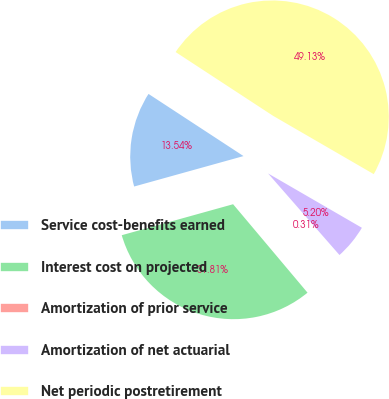Convert chart. <chart><loc_0><loc_0><loc_500><loc_500><pie_chart><fcel>Service cost-benefits earned<fcel>Interest cost on projected<fcel>Amortization of prior service<fcel>Amortization of net actuarial<fcel>Net periodic postretirement<nl><fcel>13.54%<fcel>31.81%<fcel>0.31%<fcel>5.2%<fcel>49.13%<nl></chart> 